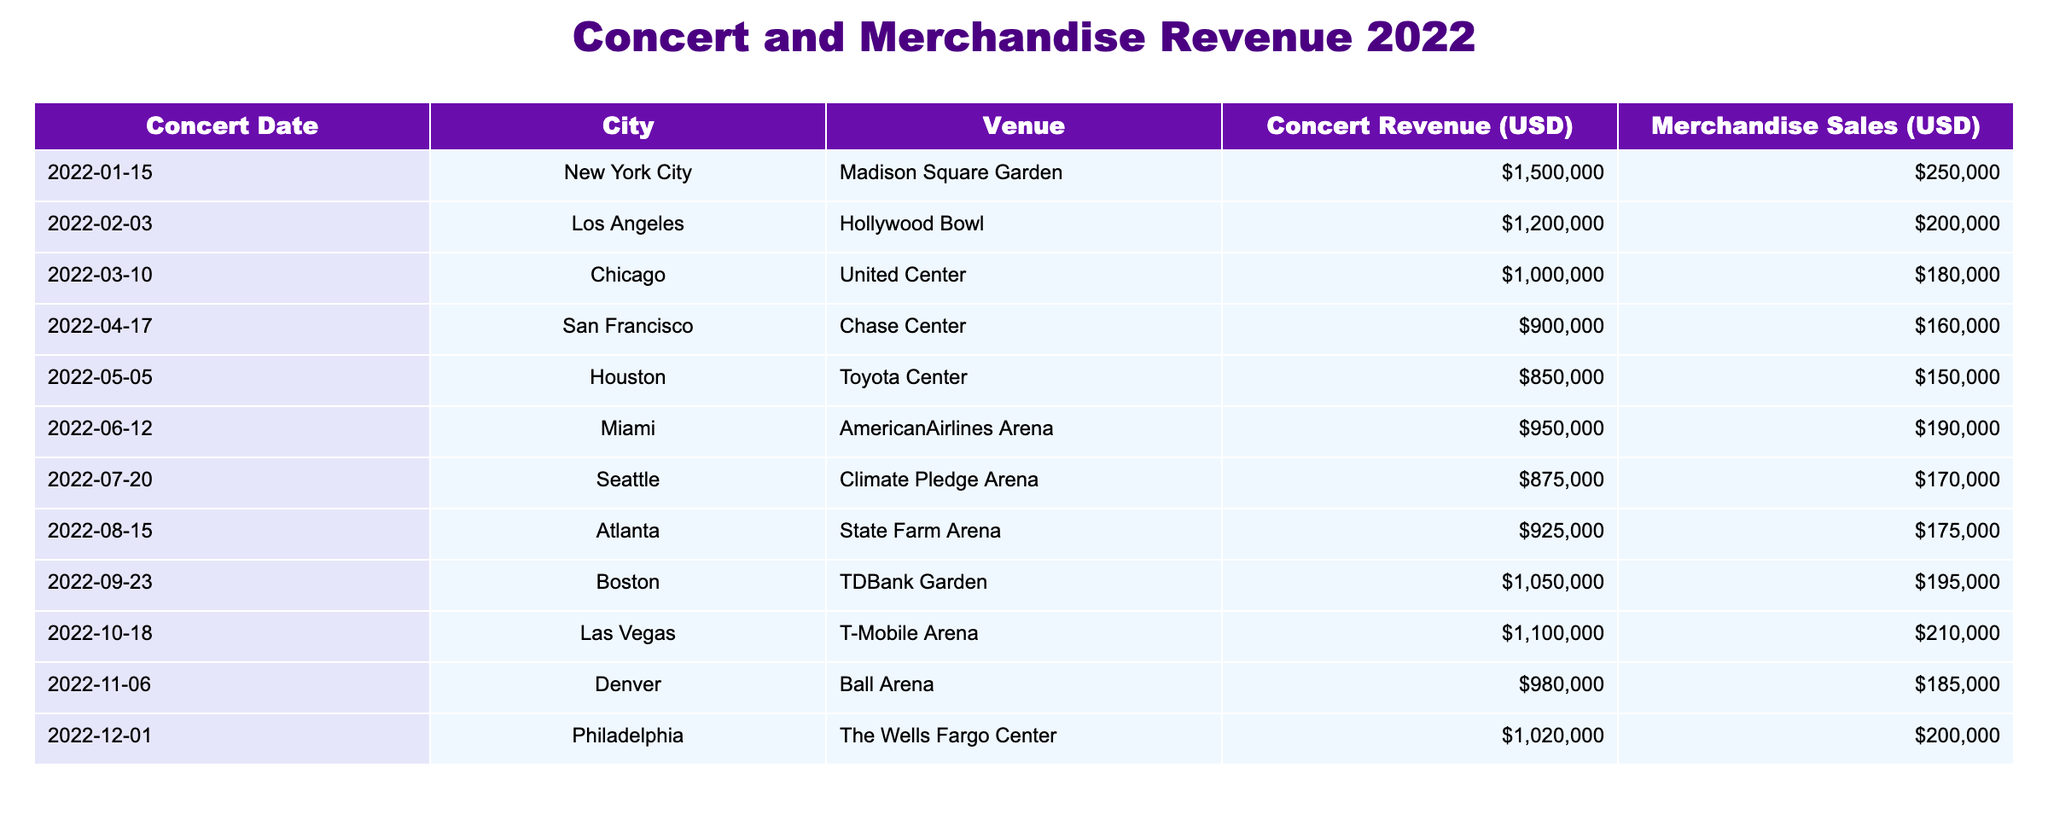What was the total concert revenue for all events in 2022? To find the total concert revenue, we sum the concert revenues for each event: 1500000 + 1200000 + 1000000 + 900000 + 850000 + 950000 + 875000 + 925000 + 1050000 + 1100000 + 980000 + 1020000 = 11650000.
Answer: 11650000 Which city had the highest merchandise sales, and what was the amount? By comparing the merchandise sales across all cities, we find the maximum value is 250000 from New York City.
Answer: New York City, 250000 What is the average concert revenue for the concerts held in 2022? We first sum all concert revenues to get 11650000. There are 12 concerts, so we divide this sum by 12. Therefore, the average concert revenue is 11650000 / 12 = 975000.
Answer: 975000 Did merchandise sales exceed concert revenue at any event? To determine this, we compare merchandise sales and concert revenue for each event. No instance shows merchandise sales exceeding concert revenue.
Answer: No What was the total revenue (concert revenue plus merchandise sales) generated in Las Vegas? For the Las Vegas concert, the concert revenue is 1100000 and merchandise sales are 210000. Adding these gives: 1100000 + 210000 = 1310000.
Answer: 1310000 Which venue had the lowest concert revenue and what was that revenue? Analyzing the concert revenue data, we find that the venue with the lowest revenue is Chase Center in San Francisco with a total revenue of 900000.
Answer: Chase Center, 900000 In which month did the concert with the second-highest merchandise sales occur, and what were the sales? We track the merchandise sales for each concert, finding the second highest is 250000 from January. The month is January 2022.
Answer: January 2022, 250000 What is the total difference in revenue from concerts between the highest and lowest earning venues? The highest concert revenue is 1500000 (New York City) and the lowest is 900000 (San Francisco). The difference is calculated as 1500000 - 900000 = 600000.
Answer: 600000 Was there any concert with revenue greater than the average concert revenue? The average concert revenue is 975000. Checking the individual revenues, several concerts (all above average) affirm the presence of events exceeding this mark, specifically in New York City, Los Angeles, Chicago, and others.
Answer: Yes 